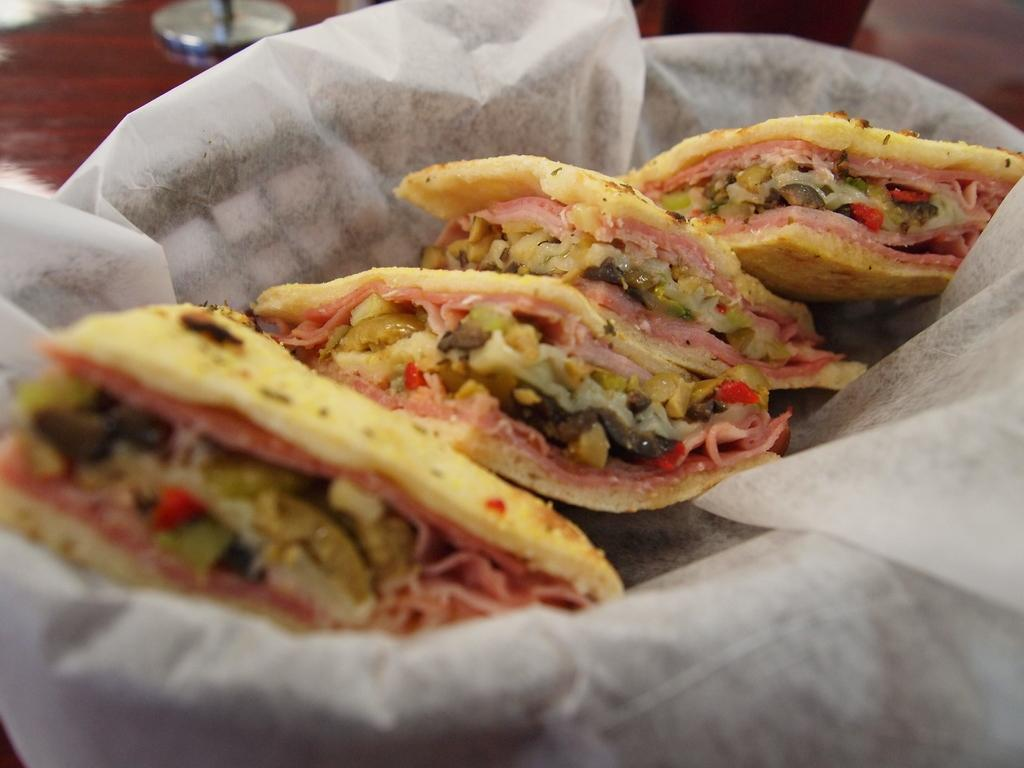What is the main object in the image? There is a bowl in the image. What is the color of the surface the bowl is on? The bowl is on a brown colored surface. What else can be seen in the image besides the bowl? There is a paper and food items in the image. What colors can be observed in the food items? The food items have various colors, including red, cream, green, and brown. What type of pin can be seen holding the paper to the door in the image? There is no pin or door present in the image; it only features a bowl, a brown surface, a paper, and food items. 